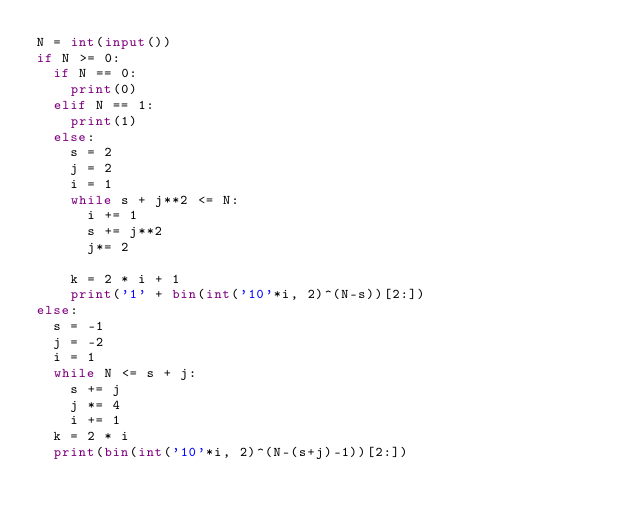Convert code to text. <code><loc_0><loc_0><loc_500><loc_500><_Python_>N = int(input())
if N >= 0:
  if N == 0:
    print(0)
  elif N == 1:
    print(1)
  else:
    s = 2
    j = 2
    i = 1
    while s + j**2 <= N:
      i += 1
      s += j**2
      j*= 2
  
    k = 2 * i + 1
    print('1' + bin(int('10'*i, 2)^(N-s))[2:])
else:
  s = -1
  j = -2
  i = 1
  while N <= s + j:
    s += j
    j *= 4
    i += 1
  k = 2 * i
  print(bin(int('10'*i, 2)^(N-(s+j)-1))[2:])</code> 